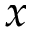Convert formula to latex. <formula><loc_0><loc_0><loc_500><loc_500>x</formula> 